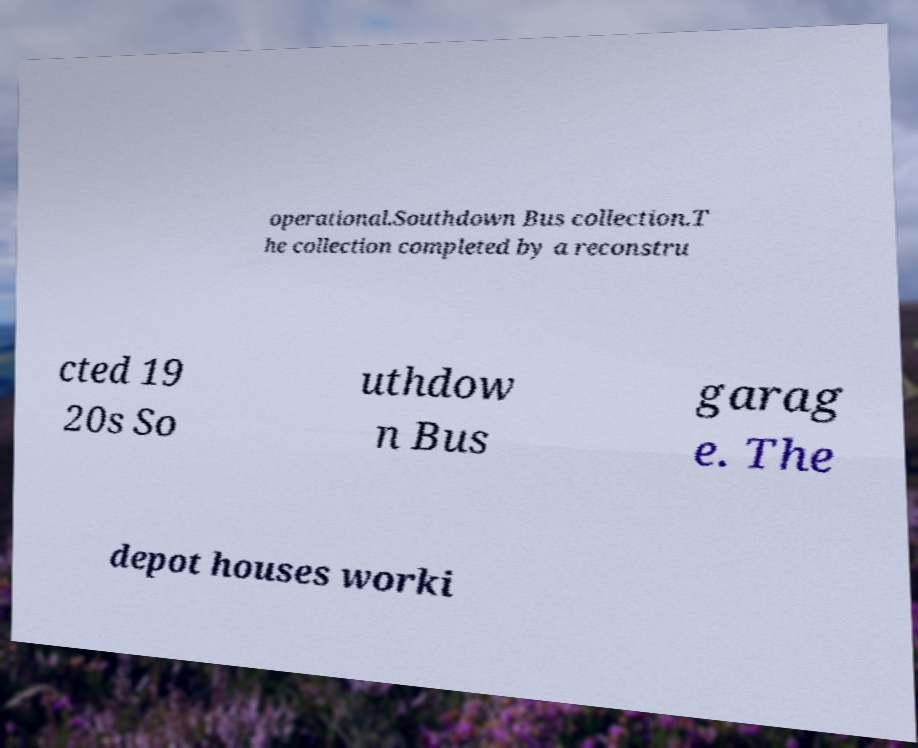Could you assist in decoding the text presented in this image and type it out clearly? operational.Southdown Bus collection.T he collection completed by a reconstru cted 19 20s So uthdow n Bus garag e. The depot houses worki 